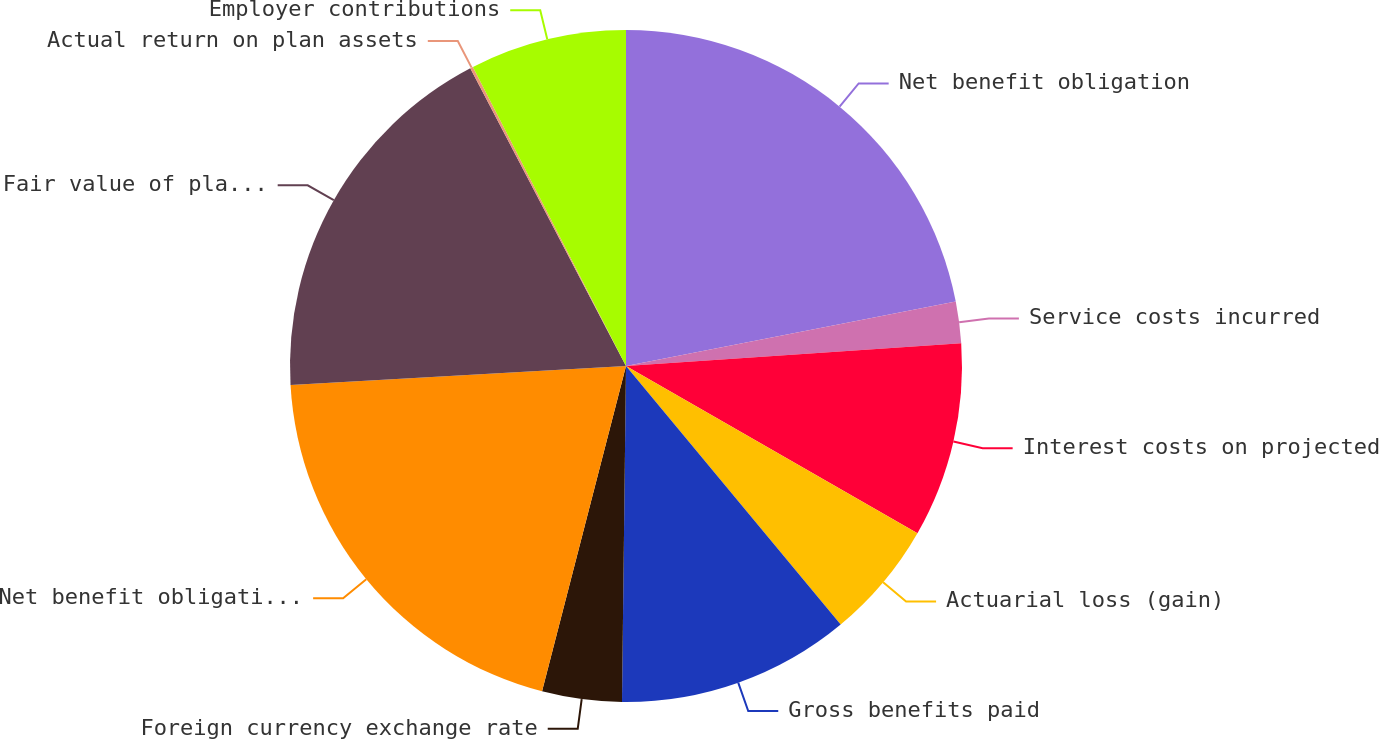Convert chart. <chart><loc_0><loc_0><loc_500><loc_500><pie_chart><fcel>Net benefit obligation<fcel>Service costs incurred<fcel>Interest costs on projected<fcel>Actuarial loss (gain)<fcel>Gross benefits paid<fcel>Foreign currency exchange rate<fcel>Net benefit obligation end of<fcel>Fair value of plan assets<fcel>Actual return on plan assets<fcel>Employer contributions<nl><fcel>21.93%<fcel>1.99%<fcel>9.37%<fcel>5.68%<fcel>11.22%<fcel>3.83%<fcel>20.08%<fcel>18.23%<fcel>0.14%<fcel>7.53%<nl></chart> 